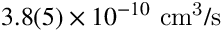<formula> <loc_0><loc_0><loc_500><loc_500>3 . 8 ( 5 ) \times 1 0 ^ { - 1 0 } { c m ^ { 3 } / s }</formula> 